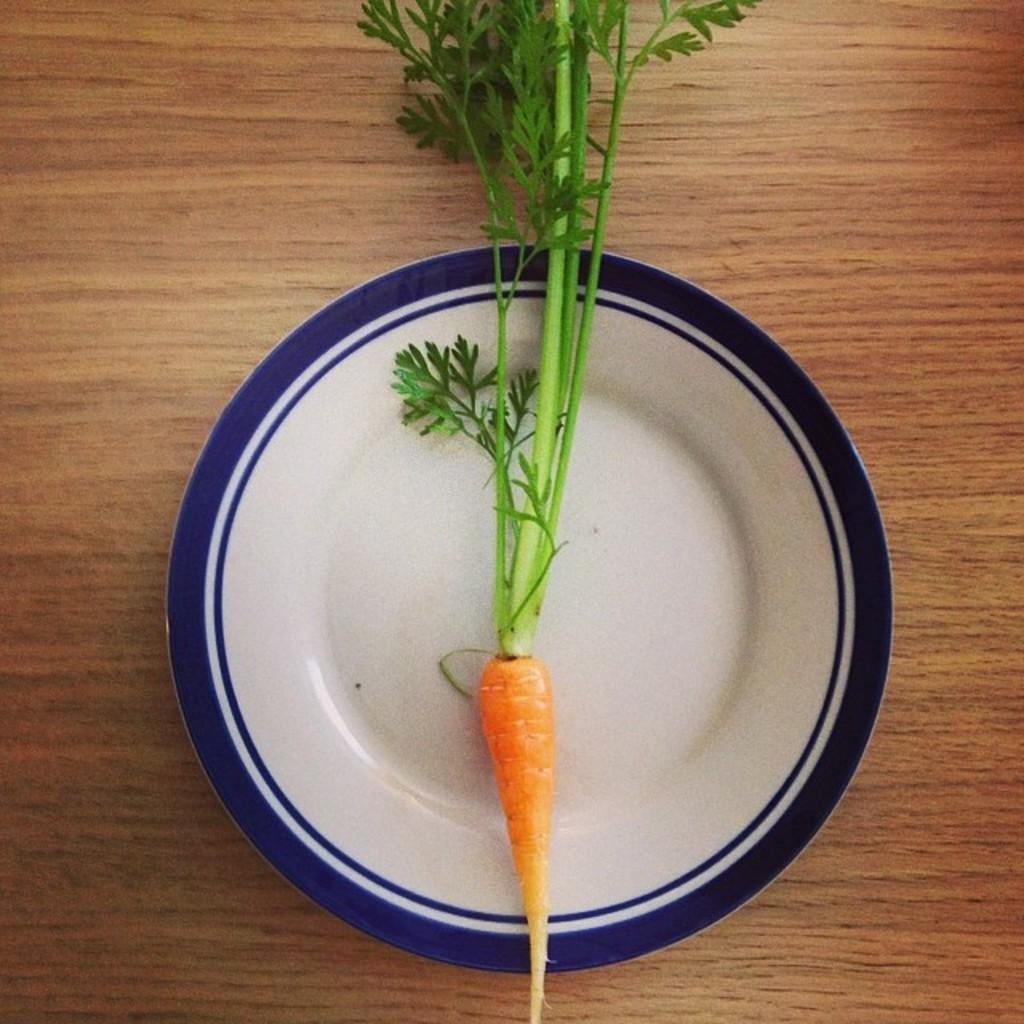What is on the table in the image? There is a plate on the table in the image. What is on the plate? There are carrots, a plant stem, and leaves on the plate. Can you describe the contents of the plate in more detail? The plate contains carrots, a plant stem, and leaves. What type of nerve can be seen on the plate in the image? There is no nerve present on the plate in the image. 